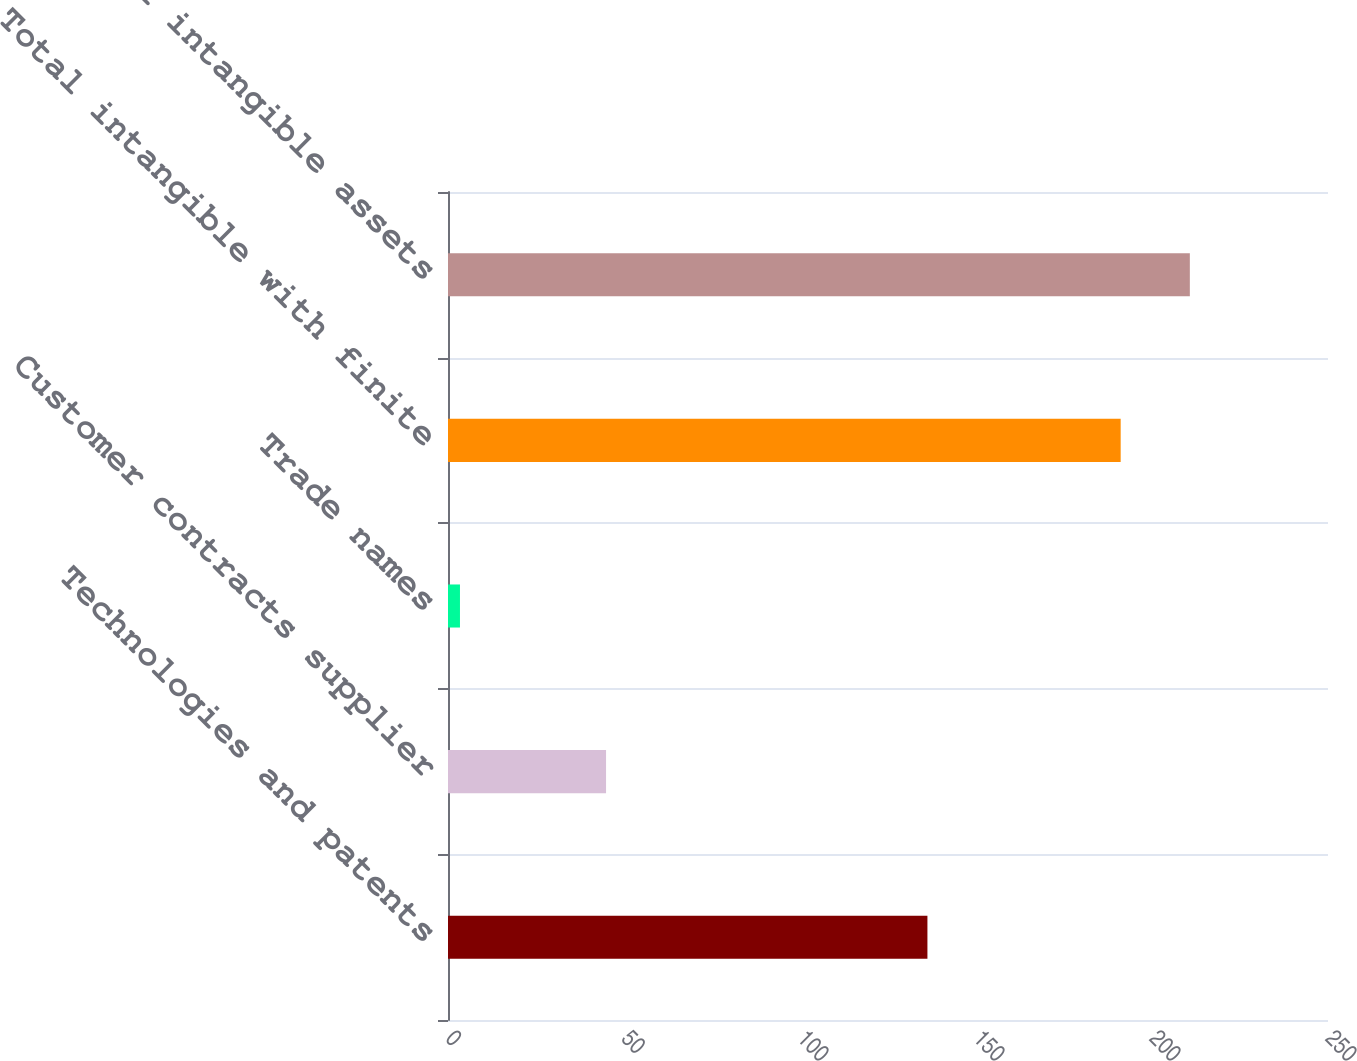Convert chart. <chart><loc_0><loc_0><loc_500><loc_500><bar_chart><fcel>Technologies and patents<fcel>Customer contracts supplier<fcel>Trade names<fcel>Total intangible with finite<fcel>Total intangible assets<nl><fcel>136.2<fcel>44.9<fcel>3.4<fcel>191.1<fcel>210.75<nl></chart> 